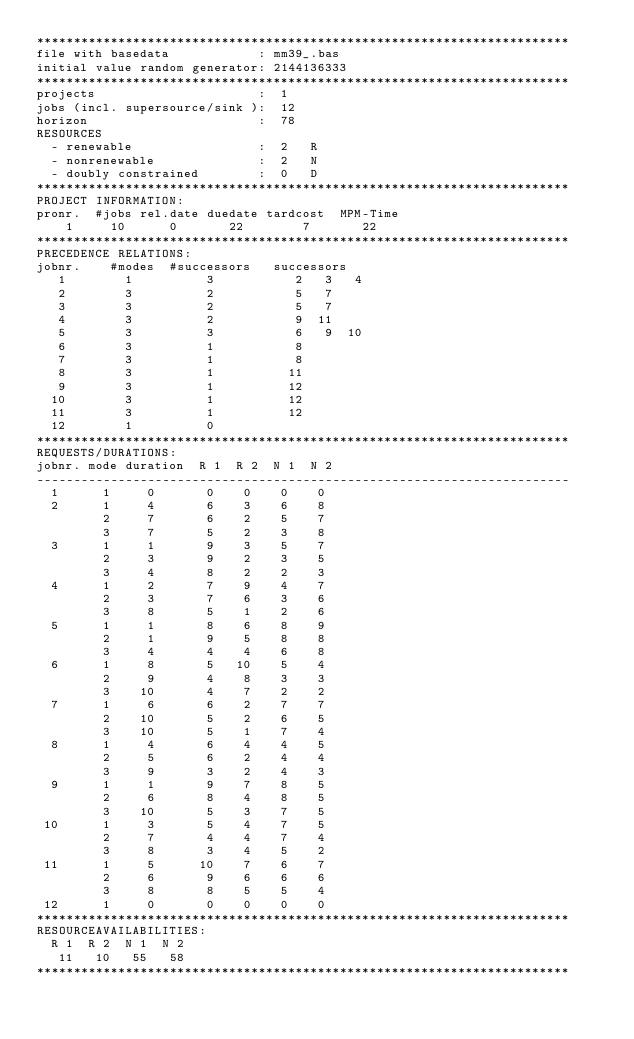Convert code to text. <code><loc_0><loc_0><loc_500><loc_500><_ObjectiveC_>************************************************************************
file with basedata            : mm39_.bas
initial value random generator: 2144136333
************************************************************************
projects                      :  1
jobs (incl. supersource/sink ):  12
horizon                       :  78
RESOURCES
  - renewable                 :  2   R
  - nonrenewable              :  2   N
  - doubly constrained        :  0   D
************************************************************************
PROJECT INFORMATION:
pronr.  #jobs rel.date duedate tardcost  MPM-Time
    1     10      0       22        7       22
************************************************************************
PRECEDENCE RELATIONS:
jobnr.    #modes  #successors   successors
   1        1          3           2   3   4
   2        3          2           5   7
   3        3          2           5   7
   4        3          2           9  11
   5        3          3           6   9  10
   6        3          1           8
   7        3          1           8
   8        3          1          11
   9        3          1          12
  10        3          1          12
  11        3          1          12
  12        1          0        
************************************************************************
REQUESTS/DURATIONS:
jobnr. mode duration  R 1  R 2  N 1  N 2
------------------------------------------------------------------------
  1      1     0       0    0    0    0
  2      1     4       6    3    6    8
         2     7       6    2    5    7
         3     7       5    2    3    8
  3      1     1       9    3    5    7
         2     3       9    2    3    5
         3     4       8    2    2    3
  4      1     2       7    9    4    7
         2     3       7    6    3    6
         3     8       5    1    2    6
  5      1     1       8    6    8    9
         2     1       9    5    8    8
         3     4       4    4    6    8
  6      1     8       5   10    5    4
         2     9       4    8    3    3
         3    10       4    7    2    2
  7      1     6       6    2    7    7
         2    10       5    2    6    5
         3    10       5    1    7    4
  8      1     4       6    4    4    5
         2     5       6    2    4    4
         3     9       3    2    4    3
  9      1     1       9    7    8    5
         2     6       8    4    8    5
         3    10       5    3    7    5
 10      1     3       5    4    7    5
         2     7       4    4    7    4
         3     8       3    4    5    2
 11      1     5      10    7    6    7
         2     6       9    6    6    6
         3     8       8    5    5    4
 12      1     0       0    0    0    0
************************************************************************
RESOURCEAVAILABILITIES:
  R 1  R 2  N 1  N 2
   11   10   55   58
************************************************************************
</code> 